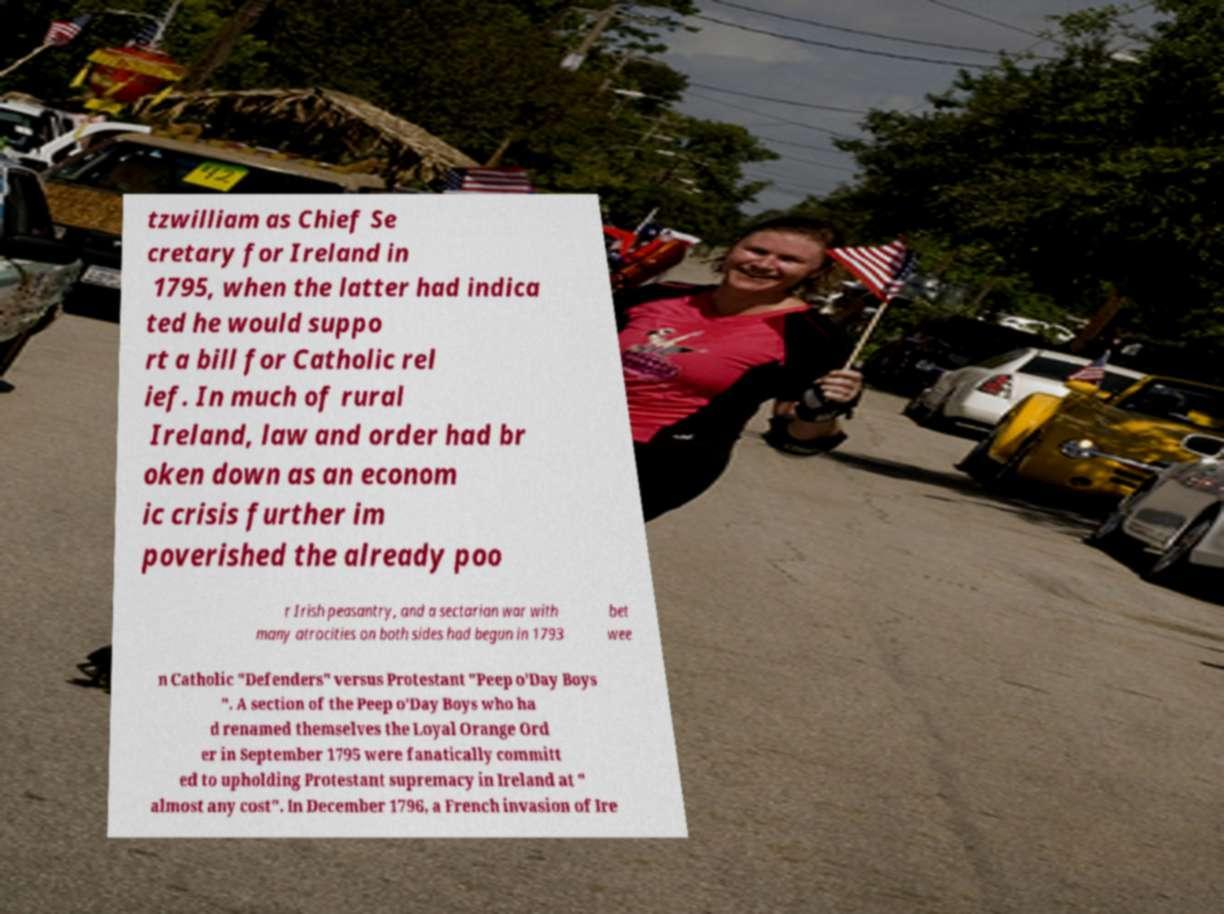Could you extract and type out the text from this image? tzwilliam as Chief Se cretary for Ireland in 1795, when the latter had indica ted he would suppo rt a bill for Catholic rel ief. In much of rural Ireland, law and order had br oken down as an econom ic crisis further im poverished the already poo r Irish peasantry, and a sectarian war with many atrocities on both sides had begun in 1793 bet wee n Catholic "Defenders" versus Protestant "Peep o'Day Boys ". A section of the Peep o'Day Boys who ha d renamed themselves the Loyal Orange Ord er in September 1795 were fanatically committ ed to upholding Protestant supremacy in Ireland at " almost any cost". In December 1796, a French invasion of Ire 